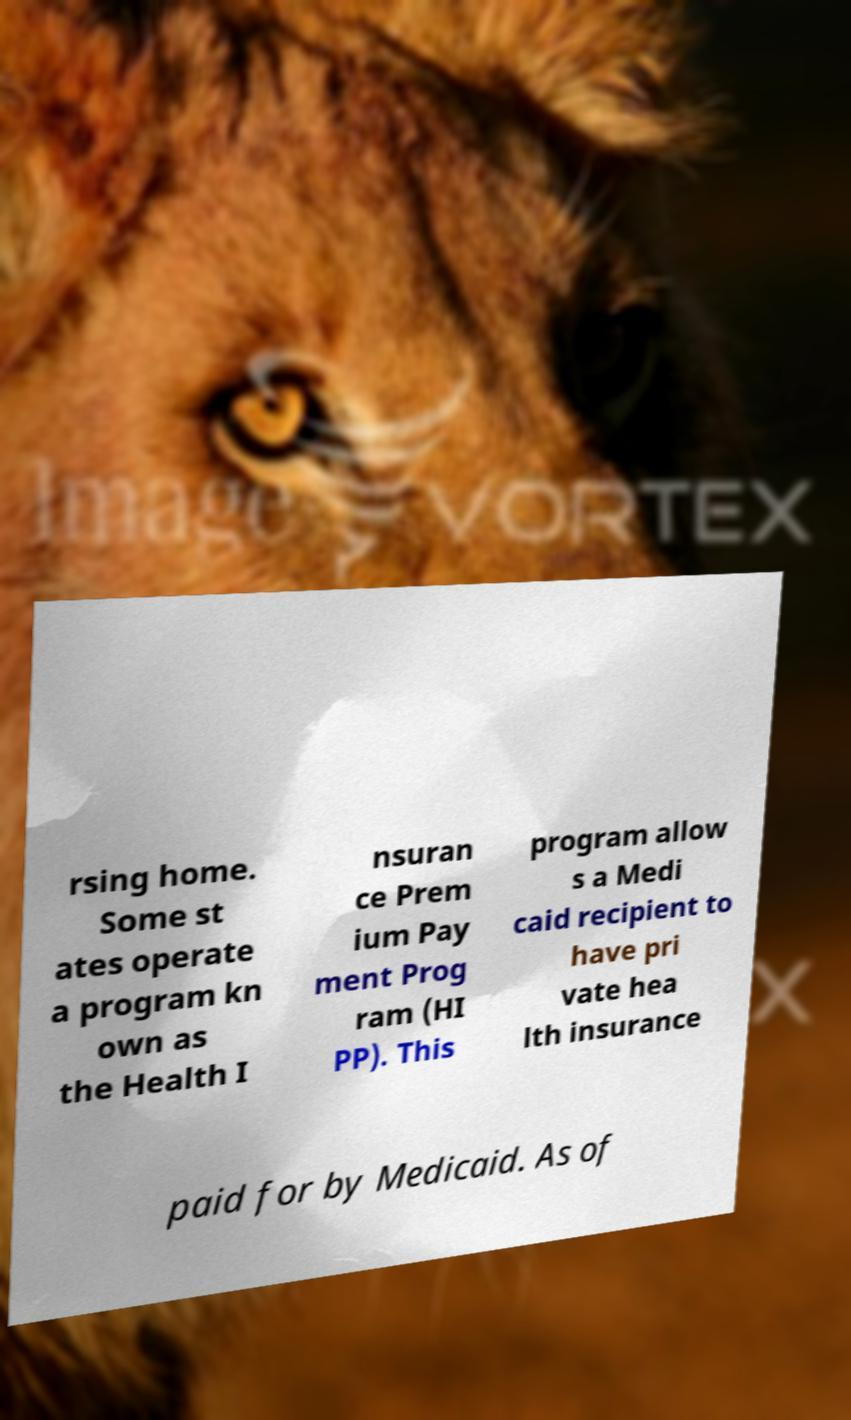There's text embedded in this image that I need extracted. Can you transcribe it verbatim? rsing home. Some st ates operate a program kn own as the Health I nsuran ce Prem ium Pay ment Prog ram (HI PP). This program allow s a Medi caid recipient to have pri vate hea lth insurance paid for by Medicaid. As of 